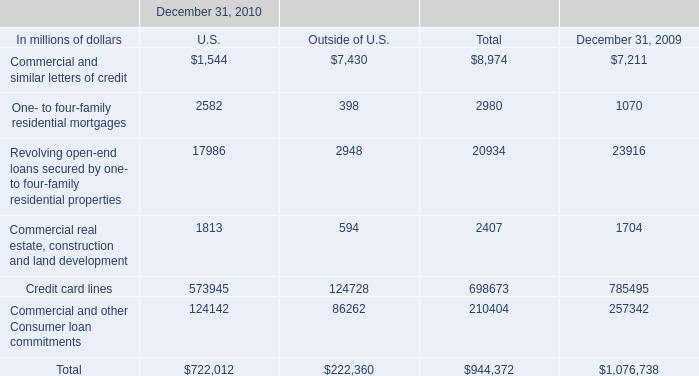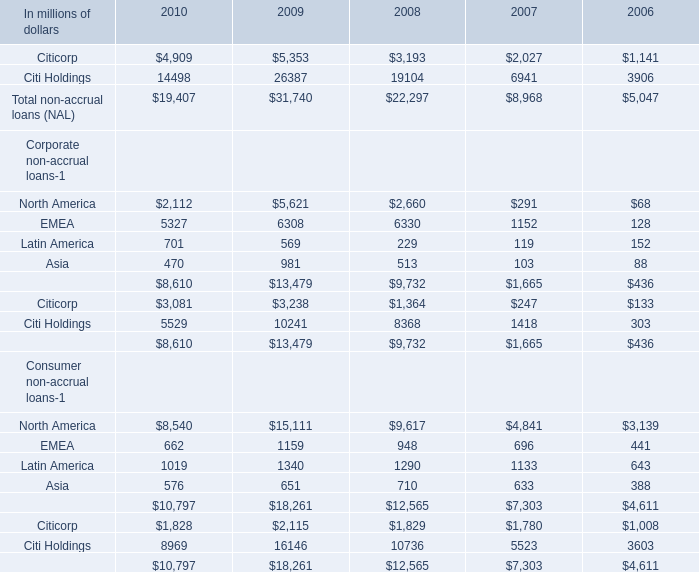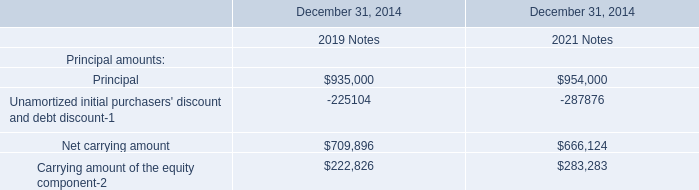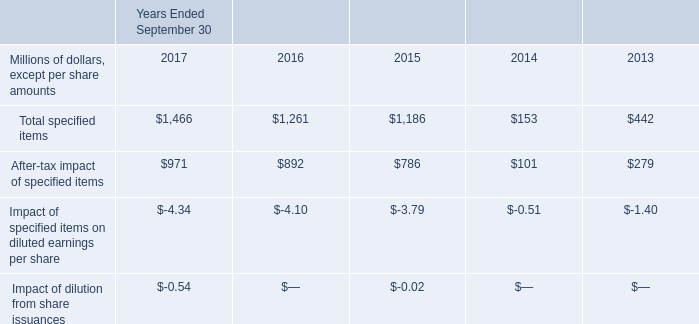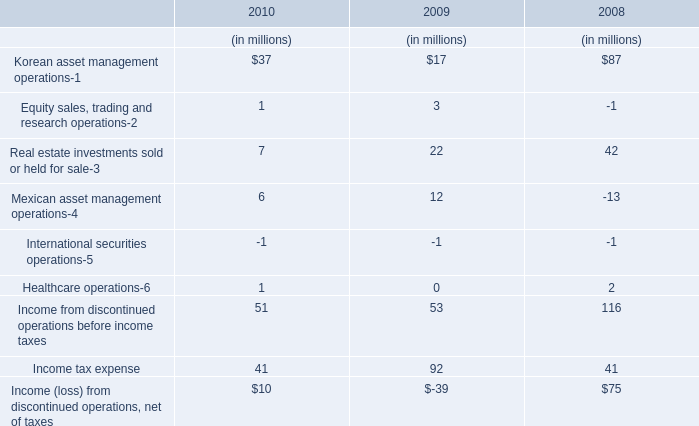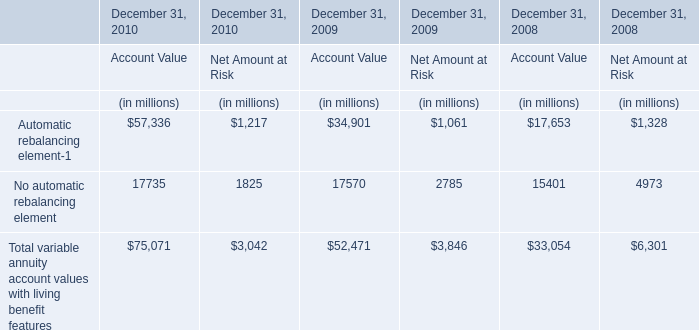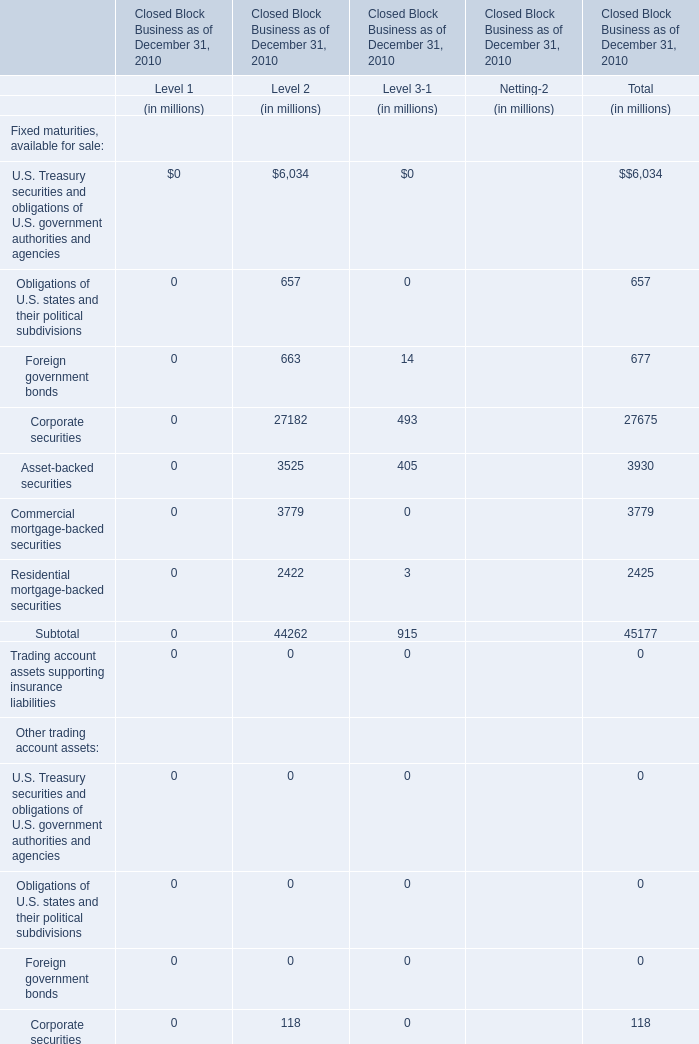Which Level is the value of the Equity securities, available for sale for Closed Block Business as of December 31, 2010 greater than 3000 million? 
Answer: 1. 